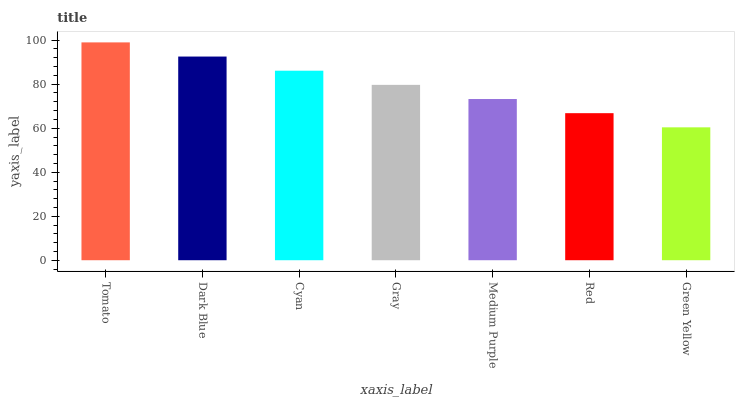Is Green Yellow the minimum?
Answer yes or no. Yes. Is Tomato the maximum?
Answer yes or no. Yes. Is Dark Blue the minimum?
Answer yes or no. No. Is Dark Blue the maximum?
Answer yes or no. No. Is Tomato greater than Dark Blue?
Answer yes or no. Yes. Is Dark Blue less than Tomato?
Answer yes or no. Yes. Is Dark Blue greater than Tomato?
Answer yes or no. No. Is Tomato less than Dark Blue?
Answer yes or no. No. Is Gray the high median?
Answer yes or no. Yes. Is Gray the low median?
Answer yes or no. Yes. Is Medium Purple the high median?
Answer yes or no. No. Is Medium Purple the low median?
Answer yes or no. No. 